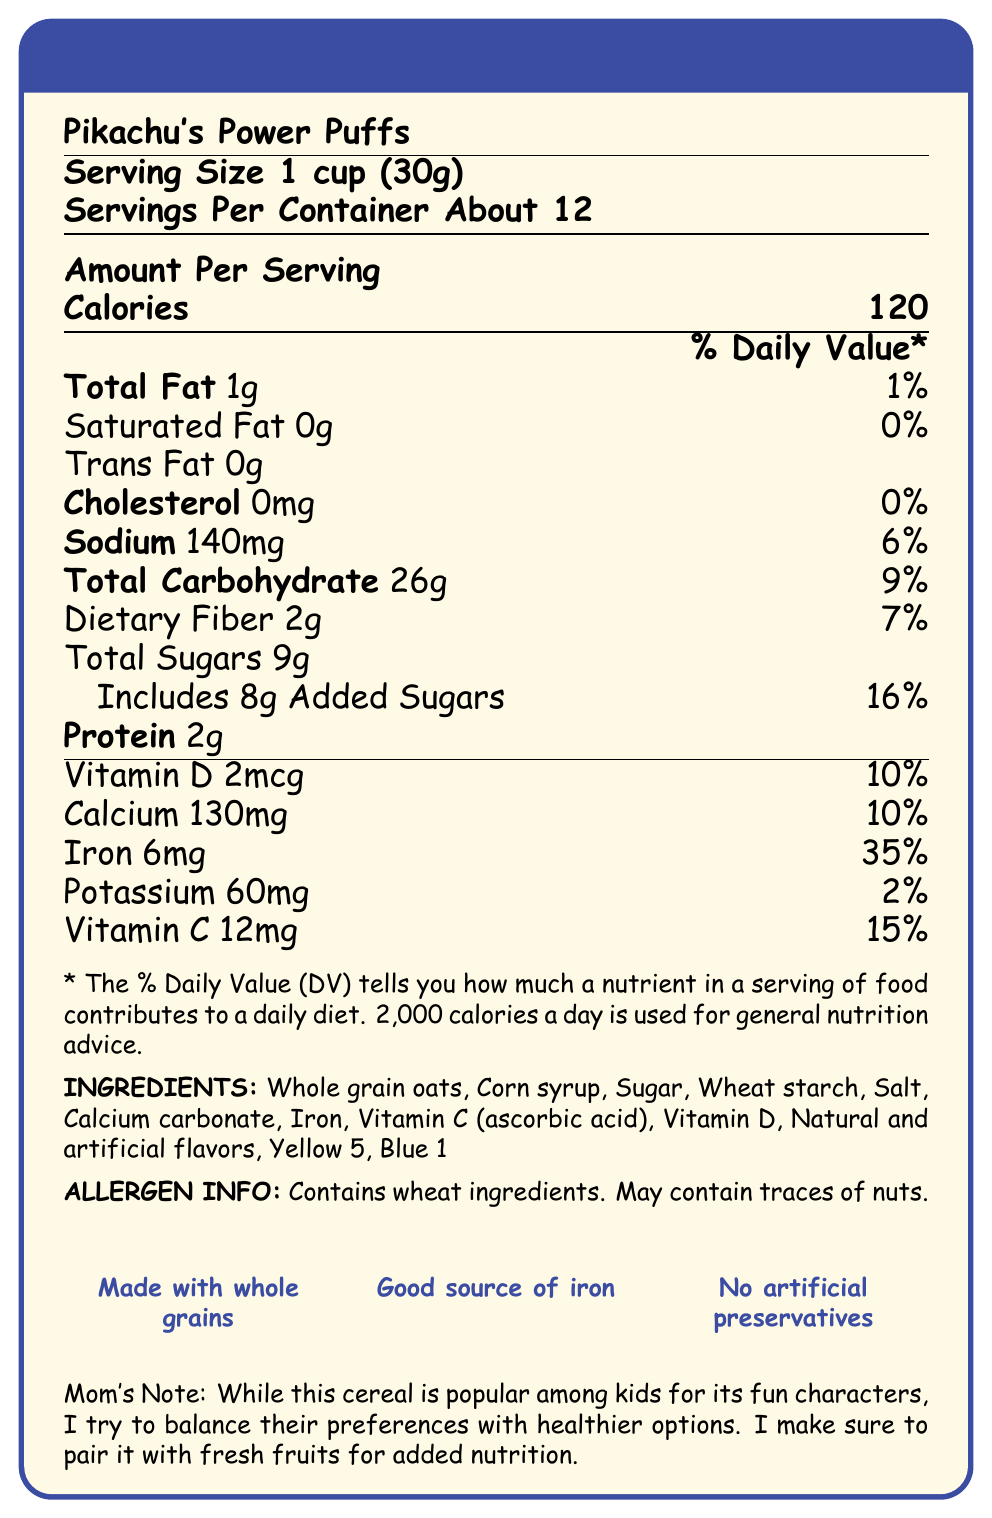what is the serving size? The document states that the serving size is 1 cup, which is equivalent to 30 grams.
Answer: 1 cup (30g) how many servings are there per container? According to the document, there are about 12 servings per container.
Answer: About 12 how many calories are in one serving of Pikachu's Power Puffs? The document indicates that each serving contains 120 calories.
Answer: 120 how much total fat is there per serving? The document lists the total fat per serving as 1 gram.
Answer: 1g what percentage of the daily value does the sodium in one serving contribute? The document states that the sodium content contributes 6% to the daily value.
Answer: 6% how much iron is there per serving in terms of percentage daily value? The document shows that the iron content per serving is 35% of the daily value.
Answer: 35% how much added sugar is included in each serving? The document specifies that each serving includes 8 grams of added sugars.
Answer: 8g which one of the following is not listed as an ingredient in Pikachu's Power Puffs? 
I. Whole grain oats
II. Corn syrup
III. Almonds
IV. Sugar The document lists the ingredients and almonds are not mentioned.
Answer: III. Almonds what are the coloring agents mentioned in the ingredients list? The document includes Yellow 5 and Blue 1 as coloring agents in the ingredients list.
Answer: Yellow 5, Blue 1 Which of the following vitamins are present in Pikachu's Power Puffs? 
A. Vitamin A
B. Vitamin B 
C. Vitamin C 
D. Vitamin D The document lists Vitamin C (12mg) and Vitamin D (2mcg) as being present in the cereal.
Answer: C, D Does Pikachu's Power Puffs contain any nuts? The document states that the product may contain traces of nuts.
Answer: May contain traces of nuts Summarize the main highlights of the Nutrition Facts Label for Pikachu's Power Puffs. The document provided detailed nutritional information about Pikachu's Power Puffs, emphasizing its vitamin and mineral content, its relatively low fat and protein content, and allergen information.
Answer: Pikachu's Power Puffs is a cereal marketed towards kids featuring Pokemon characters, with each serving size being 1 cup (30g). There are about 12 servings per container, and each serving contains 120 calories. It has low fat content (1g total fat), no cholesterol, and provides 2g of protein. The cereal is also enriched with vitamins and minerals including Vitamin D, Calcium, Iron, and Vitamin C. Ingredients include whole grain oats, corn syrup, sugar, among other additives, with allergen information indicating it contains wheat and may contain traces of nuts. how many carbs are there per serving? The document indicates that each serving contains 26 grams of total carbohydrates.
Answer: 26g Is Pikachu's Power Puffs a good source of Vitamin A? The document does not provide any information about the Vitamin A content.
Answer: Cannot be determined Does the cereal contain any artificial preservatives? The document specifically notes that the cereal has "No artificial preservatives."
Answer: No What is the main visual theme used on the box? The document describes the box art as featuring colorful Pokemon characters enjoying the cereal.
Answer: Colorful box featuring Pikachu and other Pokemon characters enjoying a bowl of cereal What is one strategy to improve the nutritional value when serving this cereal to kids? The document includes a note from a parent suggesting pairing the cereal with fresh fruits to enhance nutrition.
Answer: Pair it with fresh fruits for added nutrition 